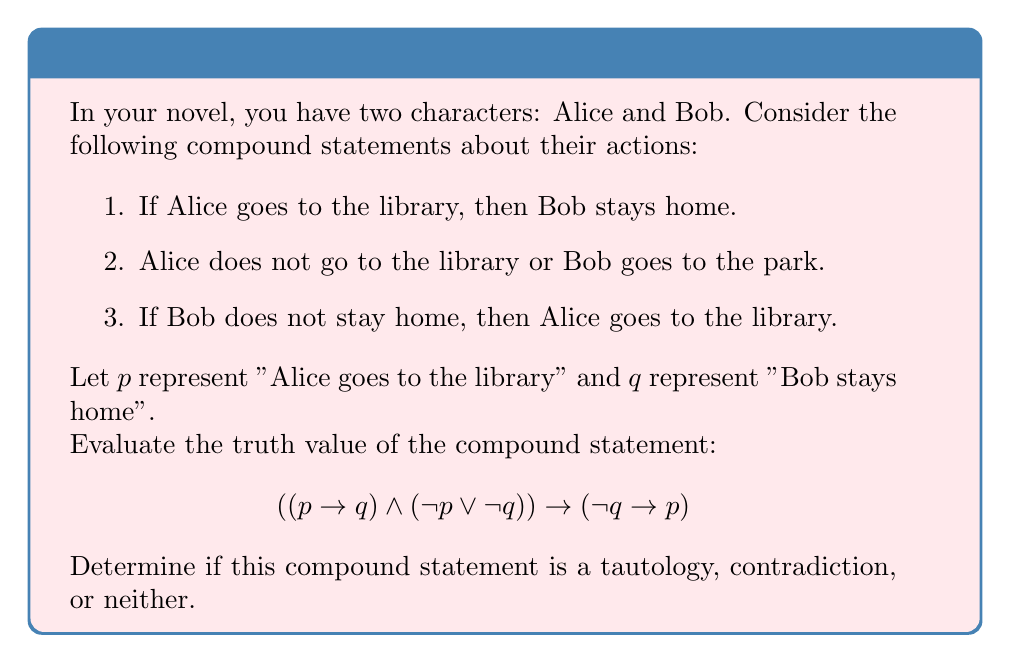Can you solve this math problem? Let's approach this step-by-step:

1) First, let's create a truth table for the given compound statement:

   $p$ | $q$ | $p \rightarrow q$ | $\lnot p \lor \lnot q$ | $(p \rightarrow q) \land (\lnot p \lor \lnot q)$ | $\lnot q \rightarrow p$ | Result
   ---|---|----------------|-------------------|----------------------------------------|-----------------|-------
   T | T |       T         |         F         |                   F                    |        T        |   T
   T | F |       F         |         T         |                   F                    |        T        |   T
   F | T |       T         |         T         |                   T                    |        F        |   F
   F | F |       T         |         T         |                   T                    |        T        |   T

2) Now, let's analyze each column:
   
   - $p \rightarrow q$ is false only when $p$ is true and $q$ is false.
   - $\lnot p \lor \lnot q$ is true except when both $p$ and $q$ are true.
   - $(p \rightarrow q) \land (\lnot p \lor \lnot q)$ is true only when both $p$ and $q$ are false.
   - $\lnot q \rightarrow p$ is false only when $q$ is false and $p$ is false.

3) The final column shows the truth value of the entire compound statement. It's false in only one case: when $p$ is false and $q$ is true.

4) For a statement to be a tautology, it must be true for all possible combinations of truth values of its component propositions. This is not the case here.

5) For a statement to be a contradiction, it must be false for all possible combinations. This is also not the case.

6) Therefore, this compound statement is neither a tautology nor a contradiction. It's a contingency, meaning its truth value depends on the truth values of its component propositions.

In the context of your novel, this means that the logical relationship between Alice's library visits and Bob's staying home is not universally true or false, but depends on the specific circumstances you create in your narrative.
Answer: Contingency 